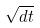<formula> <loc_0><loc_0><loc_500><loc_500>\sqrt { d t }</formula> 